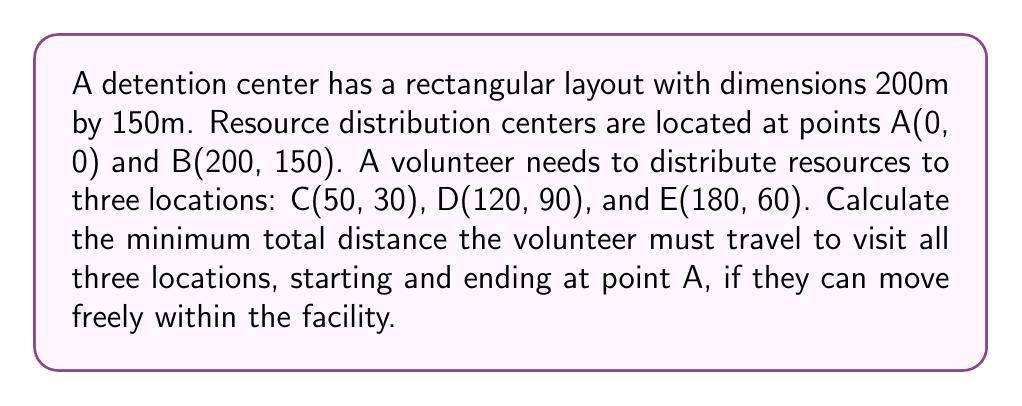What is the answer to this math problem? To solve this problem, we need to find the shortest path that connects all points. This is known as the Traveling Salesman Problem. For a small number of points, we can solve it by considering all possible routes.

Step 1: Calculate distances between all points using the distance formula:
$$d = \sqrt{(x_2-x_1)^2 + (y_2-y_1)^2}$$

$AC = \sqrt{(50-0)^2 + (30-0)^2} = \sqrt{3400} \approx 58.31$
$AD = \sqrt{(120-0)^2 + (90-0)^2} = \sqrt{22500} = 150$
$AE = \sqrt{(180-0)^2 + (60-0)^2} = \sqrt{36000} \approx 189.74$
$CD = \sqrt{(120-50)^2 + (90-30)^2} = \sqrt{9700} \approx 98.49$
$CE = \sqrt{(180-50)^2 + (60-30)^2} = \sqrt{19300} \approx 138.92$
$DE = \sqrt{(180-120)^2 + (60-90)^2} = \sqrt{4500} \approx 67.08$

Step 2: List all possible routes starting and ending at A:
1. A-C-D-E-A
2. A-C-E-D-A
3. A-D-C-E-A
4. A-D-E-C-A
5. A-E-C-D-A
6. A-E-D-C-A

Step 3: Calculate the total distance for each route:
1. A-C-D-E-A = 58.31 + 98.49 + 67.08 + 189.74 = 413.62
2. A-C-E-D-A = 58.31 + 138.92 + 67.08 + 150 = 414.31
3. A-D-C-E-A = 150 + 98.49 + 138.92 + 189.74 = 577.15
4. A-D-E-C-A = 150 + 67.08 + 138.92 + 58.31 = 414.31
5. A-E-C-D-A = 189.74 + 138.92 + 98.49 + 150 = 577.15
6. A-E-D-C-A = 189.74 + 67.08 + 98.49 + 58.31 = 413.62

Step 4: Identify the shortest route:
The shortest routes are A-C-D-E-A and A-E-D-C-A, both with a total distance of 413.62 meters.
Answer: 413.62 meters 